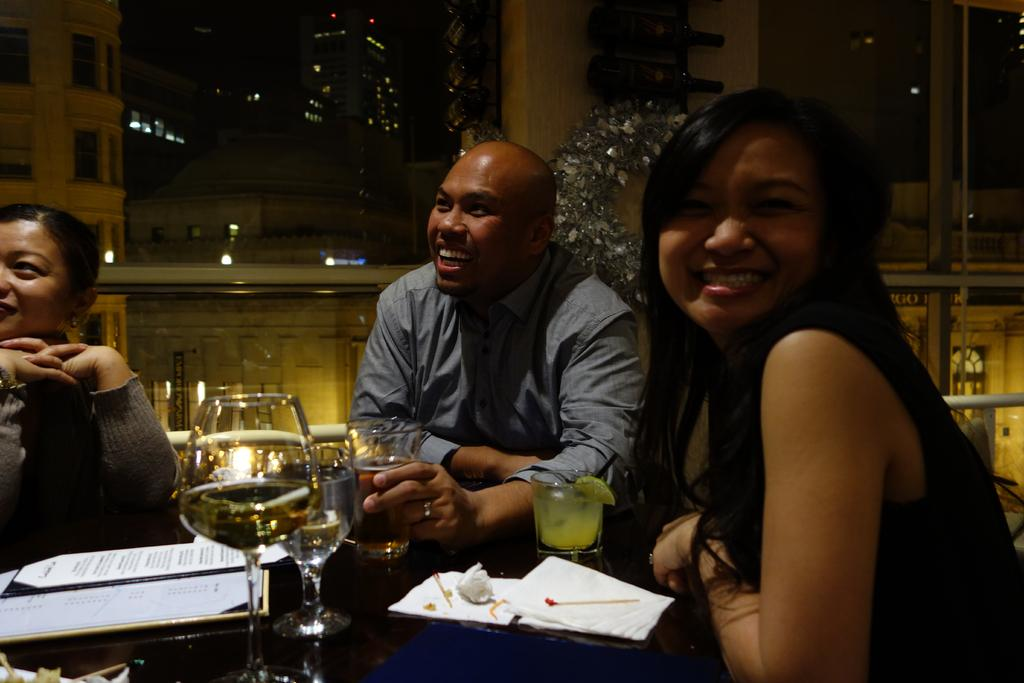How many people are in the image? There are three persons in the image. What are the persons doing in the image? The persons are sitting on chairs. What is the main piece of furniture in the image? There is a table in the image. What type of glassware can be seen in the image? There is a wine glass and a glass in the image. What type of bean is being served in the glass in the image? There is no bean present in the image; the glass contains a liquid, likely a beverage. 